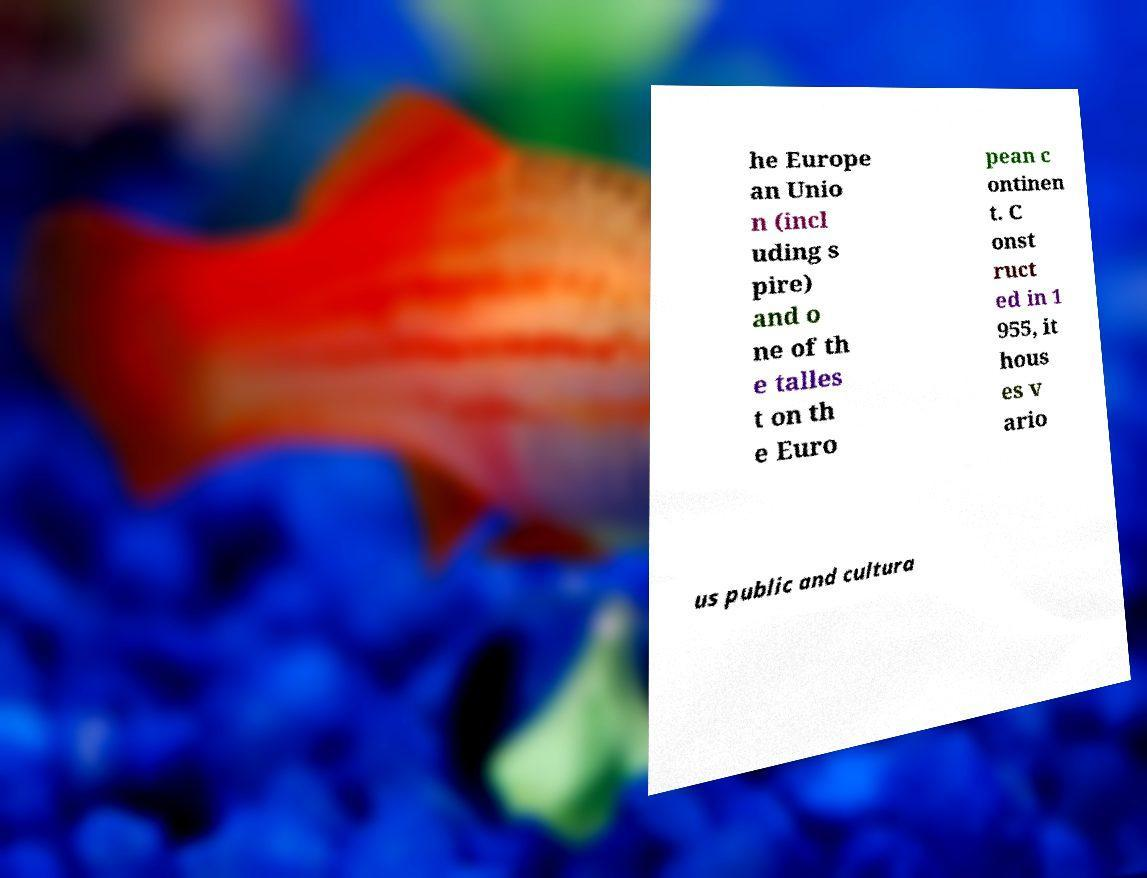Could you extract and type out the text from this image? he Europe an Unio n (incl uding s pire) and o ne of th e talles t on th e Euro pean c ontinen t. C onst ruct ed in 1 955, it hous es v ario us public and cultura 